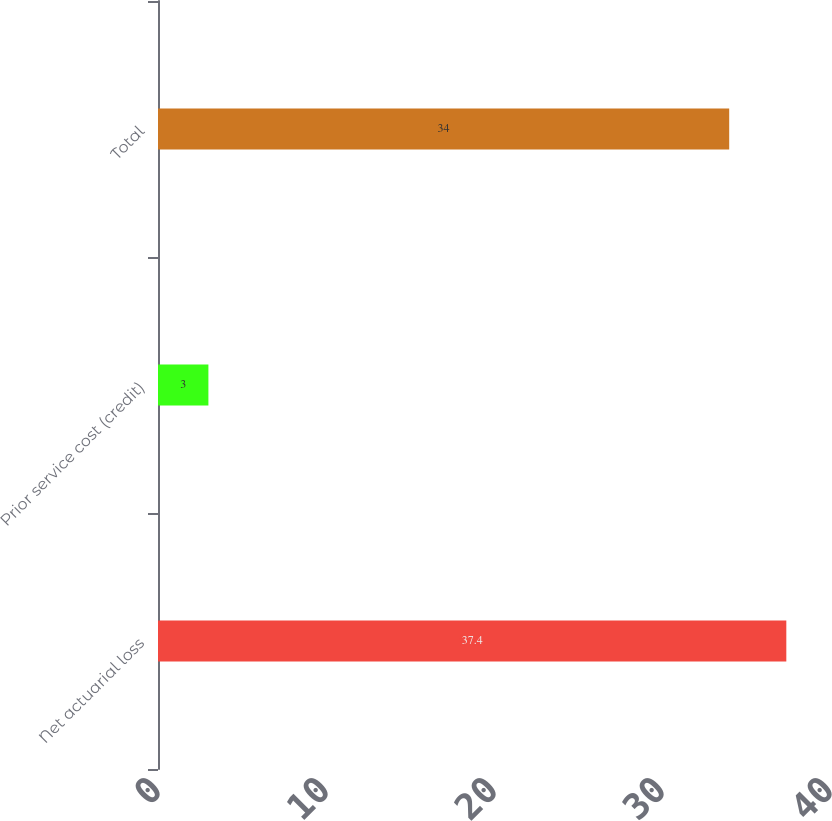Convert chart to OTSL. <chart><loc_0><loc_0><loc_500><loc_500><bar_chart><fcel>Net actuarial loss<fcel>Prior service cost (credit)<fcel>Total<nl><fcel>37.4<fcel>3<fcel>34<nl></chart> 